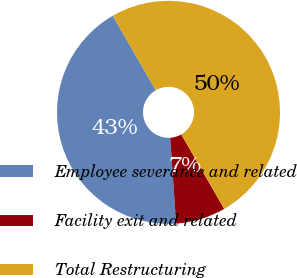Convert chart. <chart><loc_0><loc_0><loc_500><loc_500><pie_chart><fcel>Employee severance and related<fcel>Facility exit and related<fcel>Total Restructuring<nl><fcel>42.75%<fcel>7.25%<fcel>50.0%<nl></chart> 